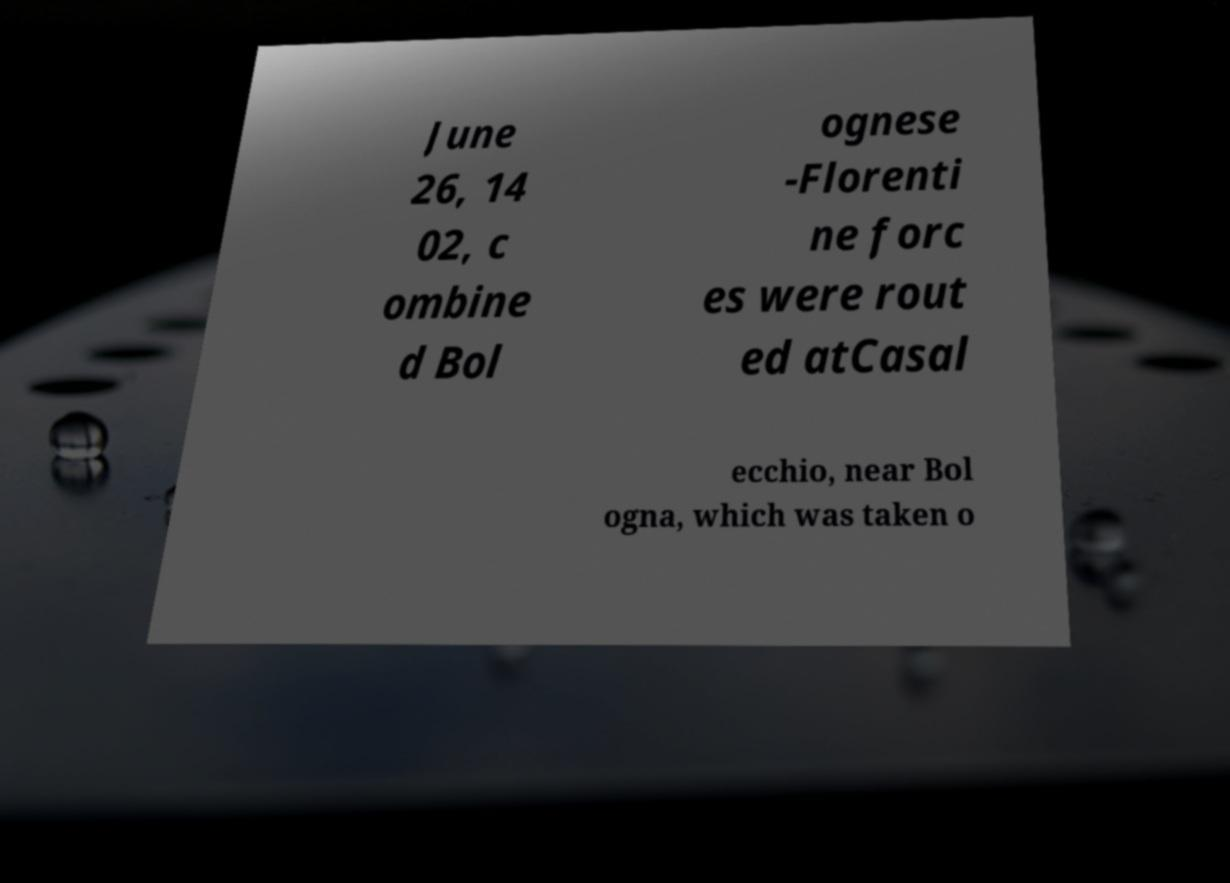Can you read and provide the text displayed in the image?This photo seems to have some interesting text. Can you extract and type it out for me? June 26, 14 02, c ombine d Bol ognese -Florenti ne forc es were rout ed atCasal ecchio, near Bol ogna, which was taken o 